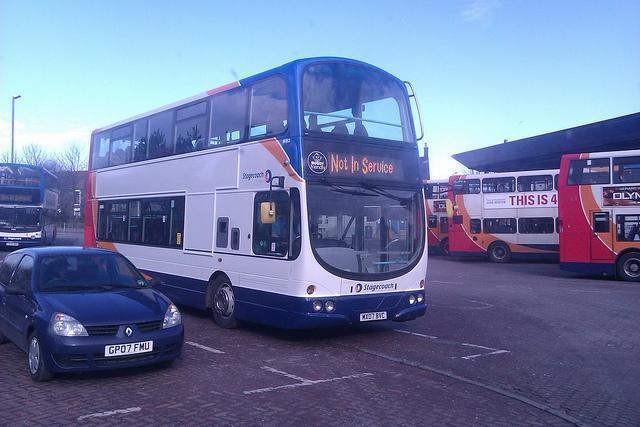How many buses are there?
Give a very brief answer. 4. How many elephants are near the rocks?
Give a very brief answer. 0. 